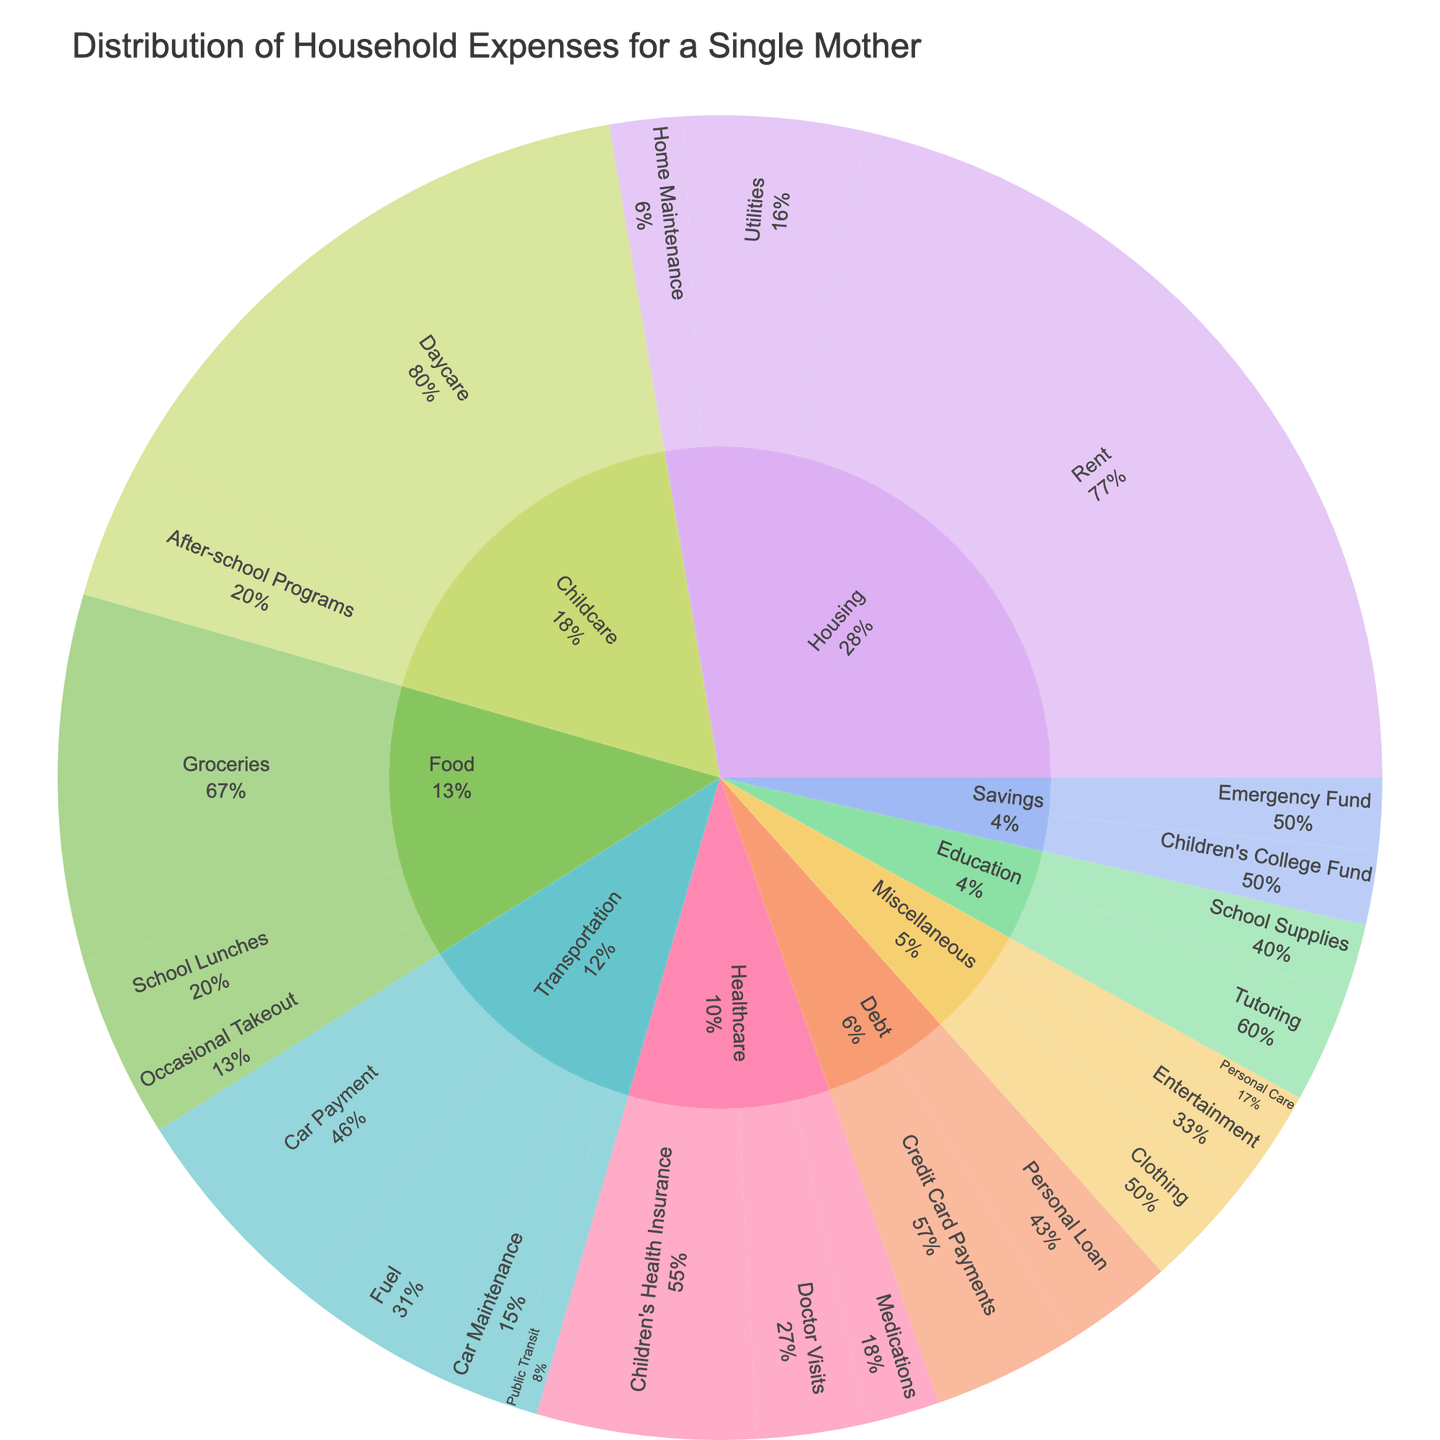What is the largest expense category? Observe the sunburst plot; the largest segment in the center represents ‘Housing’ which dominates the overall distribution.
Answer: Housing How much is spent on transportation in total? Add up the expenses listed under the 'Transportation' category: Car Payment ($300), Fuel ($200), Public Transit ($50), and Car Maintenance ($100). 300 + 200 + 50 + 100 = 650
Answer: $650 Which specific subcategory under Healthcare has the highest expense? Focus on the ‘Healthcare’ segment and identify the largest slice within it, which is ‘Children’s Health Insurance.’
Answer: Children's Health Insurance What percentage of the total expense is spent on Food? Examine the sunburst plot for the percentage label for the 'Food' category.
Answer: 12.3% How does the expense on Childcare compare to Education? Compare the total expenses under 'Childcare' (Daycare, $800 and After-school Programs, $200) to 'Education' (School Supplies, $100 and Tutoring, $150). Childcare total is $1000 vs. Education total $250. Hence, Childcare costs are higher than Education.
Answer: Childcare costs are higher What is the contribution of essential Healthcare expenses to the total budget? Add the expenses for essential Healthcare subcategories: Children's Health Insurance ($300), Medications ($100), and Doctor Visits ($150). 300 + 100 + 150 = 550. Observe the overall budget calculation to find the percentage if required.
Answer: $550 How do expenses on personal care and entertainment compare within Miscellaneous? Observe the sunburst plot under ‘Miscellaneous’ where Personal Care ($50) and Entertainment ($100) are compared side-by-side.
Answer: Entertainment is higher What is the smallest expense category? The smallest segment in the center part of the sunburst plot represents ‘Savings’.
Answer: Savings What is the sum of expenses in the Miscellaneous category? Add up the expenses under the 'Miscellaneous' category: Clothing ($150), Personal Care ($50), and Entertainment ($100). 150 + 50 + 100 = 300
Answer: $300 Which subcategory in the 'Housing' category has the least expense? Examine the subcategories within the 'Housing' section, the smallest slice is 'Home Maintenance.'
Answer: Home Maintenance 